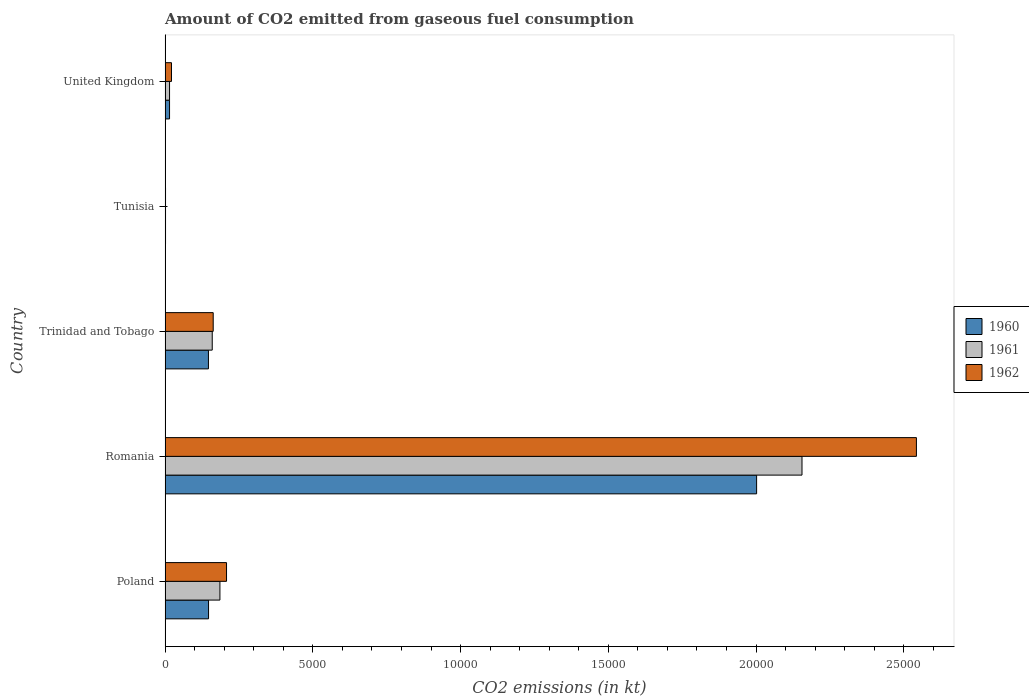How many different coloured bars are there?
Your answer should be compact. 3. Are the number of bars per tick equal to the number of legend labels?
Offer a terse response. Yes. How many bars are there on the 3rd tick from the bottom?
Offer a very short reply. 3. What is the label of the 4th group of bars from the top?
Make the answer very short. Romania. What is the amount of CO2 emitted in 1960 in United Kingdom?
Make the answer very short. 150.35. Across all countries, what is the maximum amount of CO2 emitted in 1962?
Provide a succinct answer. 2.54e+04. Across all countries, what is the minimum amount of CO2 emitted in 1961?
Provide a short and direct response. 14.67. In which country was the amount of CO2 emitted in 1961 maximum?
Your response must be concise. Romania. In which country was the amount of CO2 emitted in 1962 minimum?
Provide a short and direct response. Tunisia. What is the total amount of CO2 emitted in 1962 in the graph?
Keep it short and to the point. 2.94e+04. What is the difference between the amount of CO2 emitted in 1960 in Poland and that in Tunisia?
Ensure brevity in your answer.  1455.8. What is the difference between the amount of CO2 emitted in 1961 in Romania and the amount of CO2 emitted in 1960 in Poland?
Provide a short and direct response. 2.01e+04. What is the average amount of CO2 emitted in 1960 per country?
Your answer should be very brief. 4624.09. What is the difference between the amount of CO2 emitted in 1961 and amount of CO2 emitted in 1962 in United Kingdom?
Provide a short and direct response. -66.01. What is the ratio of the amount of CO2 emitted in 1960 in Romania to that in Trinidad and Tobago?
Your answer should be compact. 13.65. What is the difference between the highest and the second highest amount of CO2 emitted in 1962?
Give a very brief answer. 2.33e+04. What is the difference between the highest and the lowest amount of CO2 emitted in 1961?
Your response must be concise. 2.15e+04. What does the 1st bar from the bottom in Romania represents?
Offer a very short reply. 1960. How many bars are there?
Your answer should be compact. 15. Does the graph contain any zero values?
Make the answer very short. No. Where does the legend appear in the graph?
Make the answer very short. Center right. How many legend labels are there?
Your answer should be very brief. 3. What is the title of the graph?
Give a very brief answer. Amount of CO2 emitted from gaseous fuel consumption. Does "1966" appear as one of the legend labels in the graph?
Provide a succinct answer. No. What is the label or title of the X-axis?
Your response must be concise. CO2 emissions (in kt). What is the label or title of the Y-axis?
Provide a succinct answer. Country. What is the CO2 emissions (in kt) of 1960 in Poland?
Give a very brief answer. 1470.47. What is the CO2 emissions (in kt) in 1961 in Poland?
Provide a short and direct response. 1855.5. What is the CO2 emissions (in kt) of 1962 in Poland?
Your answer should be compact. 2079.19. What is the CO2 emissions (in kt) in 1960 in Romania?
Ensure brevity in your answer.  2.00e+04. What is the CO2 emissions (in kt) in 1961 in Romania?
Provide a succinct answer. 2.16e+04. What is the CO2 emissions (in kt) in 1962 in Romania?
Offer a terse response. 2.54e+04. What is the CO2 emissions (in kt) of 1960 in Trinidad and Tobago?
Your answer should be very brief. 1466.8. What is the CO2 emissions (in kt) of 1961 in Trinidad and Tobago?
Offer a very short reply. 1595.14. What is the CO2 emissions (in kt) in 1962 in Trinidad and Tobago?
Ensure brevity in your answer.  1628.15. What is the CO2 emissions (in kt) in 1960 in Tunisia?
Make the answer very short. 14.67. What is the CO2 emissions (in kt) in 1961 in Tunisia?
Make the answer very short. 14.67. What is the CO2 emissions (in kt) of 1962 in Tunisia?
Provide a short and direct response. 14.67. What is the CO2 emissions (in kt) of 1960 in United Kingdom?
Give a very brief answer. 150.35. What is the CO2 emissions (in kt) in 1961 in United Kingdom?
Your response must be concise. 150.35. What is the CO2 emissions (in kt) in 1962 in United Kingdom?
Your answer should be very brief. 216.35. Across all countries, what is the maximum CO2 emissions (in kt) of 1960?
Offer a terse response. 2.00e+04. Across all countries, what is the maximum CO2 emissions (in kt) of 1961?
Make the answer very short. 2.16e+04. Across all countries, what is the maximum CO2 emissions (in kt) of 1962?
Make the answer very short. 2.54e+04. Across all countries, what is the minimum CO2 emissions (in kt) of 1960?
Your answer should be very brief. 14.67. Across all countries, what is the minimum CO2 emissions (in kt) in 1961?
Provide a short and direct response. 14.67. Across all countries, what is the minimum CO2 emissions (in kt) in 1962?
Your answer should be very brief. 14.67. What is the total CO2 emissions (in kt) of 1960 in the graph?
Your answer should be very brief. 2.31e+04. What is the total CO2 emissions (in kt) in 1961 in the graph?
Make the answer very short. 2.52e+04. What is the total CO2 emissions (in kt) of 1962 in the graph?
Your response must be concise. 2.94e+04. What is the difference between the CO2 emissions (in kt) of 1960 in Poland and that in Romania?
Offer a terse response. -1.85e+04. What is the difference between the CO2 emissions (in kt) in 1961 in Poland and that in Romania?
Your answer should be compact. -1.97e+04. What is the difference between the CO2 emissions (in kt) in 1962 in Poland and that in Romania?
Provide a short and direct response. -2.33e+04. What is the difference between the CO2 emissions (in kt) in 1960 in Poland and that in Trinidad and Tobago?
Keep it short and to the point. 3.67. What is the difference between the CO2 emissions (in kt) in 1961 in Poland and that in Trinidad and Tobago?
Keep it short and to the point. 260.36. What is the difference between the CO2 emissions (in kt) in 1962 in Poland and that in Trinidad and Tobago?
Make the answer very short. 451.04. What is the difference between the CO2 emissions (in kt) in 1960 in Poland and that in Tunisia?
Offer a very short reply. 1455.8. What is the difference between the CO2 emissions (in kt) in 1961 in Poland and that in Tunisia?
Offer a terse response. 1840.83. What is the difference between the CO2 emissions (in kt) of 1962 in Poland and that in Tunisia?
Your answer should be very brief. 2064.52. What is the difference between the CO2 emissions (in kt) in 1960 in Poland and that in United Kingdom?
Provide a short and direct response. 1320.12. What is the difference between the CO2 emissions (in kt) in 1961 in Poland and that in United Kingdom?
Your answer should be compact. 1705.15. What is the difference between the CO2 emissions (in kt) of 1962 in Poland and that in United Kingdom?
Keep it short and to the point. 1862.84. What is the difference between the CO2 emissions (in kt) of 1960 in Romania and that in Trinidad and Tobago?
Your answer should be very brief. 1.86e+04. What is the difference between the CO2 emissions (in kt) of 1961 in Romania and that in Trinidad and Tobago?
Make the answer very short. 2.00e+04. What is the difference between the CO2 emissions (in kt) in 1962 in Romania and that in Trinidad and Tobago?
Offer a terse response. 2.38e+04. What is the difference between the CO2 emissions (in kt) in 1960 in Romania and that in Tunisia?
Give a very brief answer. 2.00e+04. What is the difference between the CO2 emissions (in kt) in 1961 in Romania and that in Tunisia?
Give a very brief answer. 2.15e+04. What is the difference between the CO2 emissions (in kt) in 1962 in Romania and that in Tunisia?
Your answer should be very brief. 2.54e+04. What is the difference between the CO2 emissions (in kt) of 1960 in Romania and that in United Kingdom?
Keep it short and to the point. 1.99e+04. What is the difference between the CO2 emissions (in kt) of 1961 in Romania and that in United Kingdom?
Your answer should be very brief. 2.14e+04. What is the difference between the CO2 emissions (in kt) in 1962 in Romania and that in United Kingdom?
Offer a very short reply. 2.52e+04. What is the difference between the CO2 emissions (in kt) of 1960 in Trinidad and Tobago and that in Tunisia?
Ensure brevity in your answer.  1452.13. What is the difference between the CO2 emissions (in kt) in 1961 in Trinidad and Tobago and that in Tunisia?
Your response must be concise. 1580.48. What is the difference between the CO2 emissions (in kt) of 1962 in Trinidad and Tobago and that in Tunisia?
Ensure brevity in your answer.  1613.48. What is the difference between the CO2 emissions (in kt) of 1960 in Trinidad and Tobago and that in United Kingdom?
Provide a succinct answer. 1316.45. What is the difference between the CO2 emissions (in kt) in 1961 in Trinidad and Tobago and that in United Kingdom?
Your response must be concise. 1444.8. What is the difference between the CO2 emissions (in kt) of 1962 in Trinidad and Tobago and that in United Kingdom?
Keep it short and to the point. 1411.8. What is the difference between the CO2 emissions (in kt) in 1960 in Tunisia and that in United Kingdom?
Give a very brief answer. -135.68. What is the difference between the CO2 emissions (in kt) in 1961 in Tunisia and that in United Kingdom?
Give a very brief answer. -135.68. What is the difference between the CO2 emissions (in kt) in 1962 in Tunisia and that in United Kingdom?
Offer a very short reply. -201.69. What is the difference between the CO2 emissions (in kt) of 1960 in Poland and the CO2 emissions (in kt) of 1961 in Romania?
Your answer should be very brief. -2.01e+04. What is the difference between the CO2 emissions (in kt) in 1960 in Poland and the CO2 emissions (in kt) in 1962 in Romania?
Keep it short and to the point. -2.40e+04. What is the difference between the CO2 emissions (in kt) of 1961 in Poland and the CO2 emissions (in kt) of 1962 in Romania?
Your answer should be compact. -2.36e+04. What is the difference between the CO2 emissions (in kt) of 1960 in Poland and the CO2 emissions (in kt) of 1961 in Trinidad and Tobago?
Your answer should be compact. -124.68. What is the difference between the CO2 emissions (in kt) of 1960 in Poland and the CO2 emissions (in kt) of 1962 in Trinidad and Tobago?
Provide a short and direct response. -157.68. What is the difference between the CO2 emissions (in kt) of 1961 in Poland and the CO2 emissions (in kt) of 1962 in Trinidad and Tobago?
Your answer should be very brief. 227.35. What is the difference between the CO2 emissions (in kt) of 1960 in Poland and the CO2 emissions (in kt) of 1961 in Tunisia?
Your response must be concise. 1455.8. What is the difference between the CO2 emissions (in kt) in 1960 in Poland and the CO2 emissions (in kt) in 1962 in Tunisia?
Provide a short and direct response. 1455.8. What is the difference between the CO2 emissions (in kt) in 1961 in Poland and the CO2 emissions (in kt) in 1962 in Tunisia?
Provide a succinct answer. 1840.83. What is the difference between the CO2 emissions (in kt) of 1960 in Poland and the CO2 emissions (in kt) of 1961 in United Kingdom?
Your answer should be very brief. 1320.12. What is the difference between the CO2 emissions (in kt) in 1960 in Poland and the CO2 emissions (in kt) in 1962 in United Kingdom?
Provide a short and direct response. 1254.11. What is the difference between the CO2 emissions (in kt) in 1961 in Poland and the CO2 emissions (in kt) in 1962 in United Kingdom?
Provide a succinct answer. 1639.15. What is the difference between the CO2 emissions (in kt) of 1960 in Romania and the CO2 emissions (in kt) of 1961 in Trinidad and Tobago?
Keep it short and to the point. 1.84e+04. What is the difference between the CO2 emissions (in kt) in 1960 in Romania and the CO2 emissions (in kt) in 1962 in Trinidad and Tobago?
Ensure brevity in your answer.  1.84e+04. What is the difference between the CO2 emissions (in kt) of 1961 in Romania and the CO2 emissions (in kt) of 1962 in Trinidad and Tobago?
Your answer should be compact. 1.99e+04. What is the difference between the CO2 emissions (in kt) of 1960 in Romania and the CO2 emissions (in kt) of 1961 in Tunisia?
Offer a very short reply. 2.00e+04. What is the difference between the CO2 emissions (in kt) in 1960 in Romania and the CO2 emissions (in kt) in 1962 in Tunisia?
Give a very brief answer. 2.00e+04. What is the difference between the CO2 emissions (in kt) in 1961 in Romania and the CO2 emissions (in kt) in 1962 in Tunisia?
Make the answer very short. 2.15e+04. What is the difference between the CO2 emissions (in kt) of 1960 in Romania and the CO2 emissions (in kt) of 1961 in United Kingdom?
Provide a succinct answer. 1.99e+04. What is the difference between the CO2 emissions (in kt) in 1960 in Romania and the CO2 emissions (in kt) in 1962 in United Kingdom?
Provide a succinct answer. 1.98e+04. What is the difference between the CO2 emissions (in kt) in 1961 in Romania and the CO2 emissions (in kt) in 1962 in United Kingdom?
Give a very brief answer. 2.13e+04. What is the difference between the CO2 emissions (in kt) of 1960 in Trinidad and Tobago and the CO2 emissions (in kt) of 1961 in Tunisia?
Ensure brevity in your answer.  1452.13. What is the difference between the CO2 emissions (in kt) of 1960 in Trinidad and Tobago and the CO2 emissions (in kt) of 1962 in Tunisia?
Make the answer very short. 1452.13. What is the difference between the CO2 emissions (in kt) of 1961 in Trinidad and Tobago and the CO2 emissions (in kt) of 1962 in Tunisia?
Provide a succinct answer. 1580.48. What is the difference between the CO2 emissions (in kt) in 1960 in Trinidad and Tobago and the CO2 emissions (in kt) in 1961 in United Kingdom?
Ensure brevity in your answer.  1316.45. What is the difference between the CO2 emissions (in kt) of 1960 in Trinidad and Tobago and the CO2 emissions (in kt) of 1962 in United Kingdom?
Give a very brief answer. 1250.45. What is the difference between the CO2 emissions (in kt) in 1961 in Trinidad and Tobago and the CO2 emissions (in kt) in 1962 in United Kingdom?
Offer a terse response. 1378.79. What is the difference between the CO2 emissions (in kt) in 1960 in Tunisia and the CO2 emissions (in kt) in 1961 in United Kingdom?
Your response must be concise. -135.68. What is the difference between the CO2 emissions (in kt) in 1960 in Tunisia and the CO2 emissions (in kt) in 1962 in United Kingdom?
Provide a succinct answer. -201.69. What is the difference between the CO2 emissions (in kt) of 1961 in Tunisia and the CO2 emissions (in kt) of 1962 in United Kingdom?
Your answer should be compact. -201.69. What is the average CO2 emissions (in kt) in 1960 per country?
Your answer should be very brief. 4624.09. What is the average CO2 emissions (in kt) of 1961 per country?
Keep it short and to the point. 5034.06. What is the average CO2 emissions (in kt) of 1962 per country?
Provide a short and direct response. 5873.07. What is the difference between the CO2 emissions (in kt) in 1960 and CO2 emissions (in kt) in 1961 in Poland?
Provide a succinct answer. -385.04. What is the difference between the CO2 emissions (in kt) in 1960 and CO2 emissions (in kt) in 1962 in Poland?
Your answer should be very brief. -608.72. What is the difference between the CO2 emissions (in kt) in 1961 and CO2 emissions (in kt) in 1962 in Poland?
Your answer should be very brief. -223.69. What is the difference between the CO2 emissions (in kt) of 1960 and CO2 emissions (in kt) of 1961 in Romania?
Ensure brevity in your answer.  -1536.47. What is the difference between the CO2 emissions (in kt) of 1960 and CO2 emissions (in kt) of 1962 in Romania?
Offer a terse response. -5408.82. What is the difference between the CO2 emissions (in kt) in 1961 and CO2 emissions (in kt) in 1962 in Romania?
Keep it short and to the point. -3872.35. What is the difference between the CO2 emissions (in kt) of 1960 and CO2 emissions (in kt) of 1961 in Trinidad and Tobago?
Make the answer very short. -128.34. What is the difference between the CO2 emissions (in kt) in 1960 and CO2 emissions (in kt) in 1962 in Trinidad and Tobago?
Your answer should be very brief. -161.35. What is the difference between the CO2 emissions (in kt) in 1961 and CO2 emissions (in kt) in 1962 in Trinidad and Tobago?
Provide a short and direct response. -33. What is the difference between the CO2 emissions (in kt) of 1960 and CO2 emissions (in kt) of 1961 in United Kingdom?
Make the answer very short. 0. What is the difference between the CO2 emissions (in kt) in 1960 and CO2 emissions (in kt) in 1962 in United Kingdom?
Your answer should be compact. -66.01. What is the difference between the CO2 emissions (in kt) in 1961 and CO2 emissions (in kt) in 1962 in United Kingdom?
Your answer should be very brief. -66.01. What is the ratio of the CO2 emissions (in kt) in 1960 in Poland to that in Romania?
Provide a succinct answer. 0.07. What is the ratio of the CO2 emissions (in kt) of 1961 in Poland to that in Romania?
Ensure brevity in your answer.  0.09. What is the ratio of the CO2 emissions (in kt) in 1962 in Poland to that in Romania?
Make the answer very short. 0.08. What is the ratio of the CO2 emissions (in kt) of 1960 in Poland to that in Trinidad and Tobago?
Your answer should be compact. 1. What is the ratio of the CO2 emissions (in kt) of 1961 in Poland to that in Trinidad and Tobago?
Keep it short and to the point. 1.16. What is the ratio of the CO2 emissions (in kt) in 1962 in Poland to that in Trinidad and Tobago?
Make the answer very short. 1.28. What is the ratio of the CO2 emissions (in kt) of 1960 in Poland to that in Tunisia?
Keep it short and to the point. 100.25. What is the ratio of the CO2 emissions (in kt) of 1961 in Poland to that in Tunisia?
Your answer should be very brief. 126.5. What is the ratio of the CO2 emissions (in kt) in 1962 in Poland to that in Tunisia?
Offer a terse response. 141.75. What is the ratio of the CO2 emissions (in kt) of 1960 in Poland to that in United Kingdom?
Offer a terse response. 9.78. What is the ratio of the CO2 emissions (in kt) of 1961 in Poland to that in United Kingdom?
Provide a short and direct response. 12.34. What is the ratio of the CO2 emissions (in kt) in 1962 in Poland to that in United Kingdom?
Ensure brevity in your answer.  9.61. What is the ratio of the CO2 emissions (in kt) of 1960 in Romania to that in Trinidad and Tobago?
Provide a short and direct response. 13.65. What is the ratio of the CO2 emissions (in kt) of 1961 in Romania to that in Trinidad and Tobago?
Ensure brevity in your answer.  13.51. What is the ratio of the CO2 emissions (in kt) in 1962 in Romania to that in Trinidad and Tobago?
Your response must be concise. 15.62. What is the ratio of the CO2 emissions (in kt) of 1960 in Romania to that in Tunisia?
Provide a short and direct response. 1364.75. What is the ratio of the CO2 emissions (in kt) in 1961 in Romania to that in Tunisia?
Keep it short and to the point. 1469.5. What is the ratio of the CO2 emissions (in kt) in 1962 in Romania to that in Tunisia?
Make the answer very short. 1733.5. What is the ratio of the CO2 emissions (in kt) in 1960 in Romania to that in United Kingdom?
Your answer should be very brief. 133.15. What is the ratio of the CO2 emissions (in kt) of 1961 in Romania to that in United Kingdom?
Your answer should be very brief. 143.37. What is the ratio of the CO2 emissions (in kt) in 1962 in Romania to that in United Kingdom?
Give a very brief answer. 117.53. What is the ratio of the CO2 emissions (in kt) of 1960 in Trinidad and Tobago to that in Tunisia?
Provide a short and direct response. 100. What is the ratio of the CO2 emissions (in kt) in 1961 in Trinidad and Tobago to that in Tunisia?
Give a very brief answer. 108.75. What is the ratio of the CO2 emissions (in kt) of 1962 in Trinidad and Tobago to that in Tunisia?
Your answer should be very brief. 111. What is the ratio of the CO2 emissions (in kt) of 1960 in Trinidad and Tobago to that in United Kingdom?
Give a very brief answer. 9.76. What is the ratio of the CO2 emissions (in kt) in 1961 in Trinidad and Tobago to that in United Kingdom?
Provide a succinct answer. 10.61. What is the ratio of the CO2 emissions (in kt) of 1962 in Trinidad and Tobago to that in United Kingdom?
Your answer should be compact. 7.53. What is the ratio of the CO2 emissions (in kt) in 1960 in Tunisia to that in United Kingdom?
Offer a very short reply. 0.1. What is the ratio of the CO2 emissions (in kt) of 1961 in Tunisia to that in United Kingdom?
Your response must be concise. 0.1. What is the ratio of the CO2 emissions (in kt) in 1962 in Tunisia to that in United Kingdom?
Provide a succinct answer. 0.07. What is the difference between the highest and the second highest CO2 emissions (in kt) in 1960?
Make the answer very short. 1.85e+04. What is the difference between the highest and the second highest CO2 emissions (in kt) in 1961?
Make the answer very short. 1.97e+04. What is the difference between the highest and the second highest CO2 emissions (in kt) in 1962?
Your response must be concise. 2.33e+04. What is the difference between the highest and the lowest CO2 emissions (in kt) in 1960?
Provide a short and direct response. 2.00e+04. What is the difference between the highest and the lowest CO2 emissions (in kt) in 1961?
Provide a short and direct response. 2.15e+04. What is the difference between the highest and the lowest CO2 emissions (in kt) in 1962?
Give a very brief answer. 2.54e+04. 